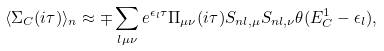Convert formula to latex. <formula><loc_0><loc_0><loc_500><loc_500>\langle \Sigma _ { C } ( i \tau ) \rangle _ { n } \approx \mp \sum _ { l \mu \nu } e ^ { \epsilon _ { l } \tau } \Pi _ { \mu \nu } ( i \tau ) S _ { n l , \mu } S _ { n l , \nu } \theta ( E ^ { 1 } _ { C } - \epsilon _ { l } ) ,</formula> 